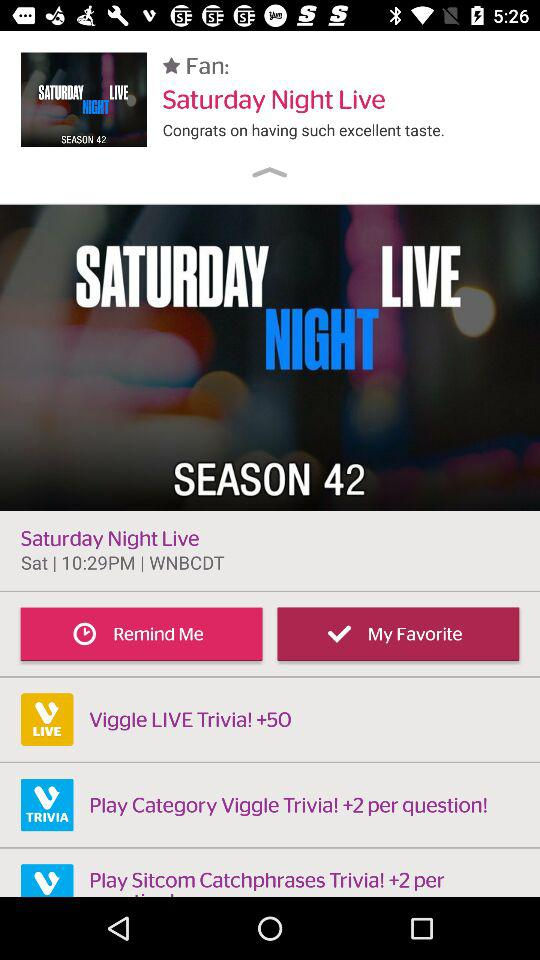What is the day of the show? The day is Saturday. 